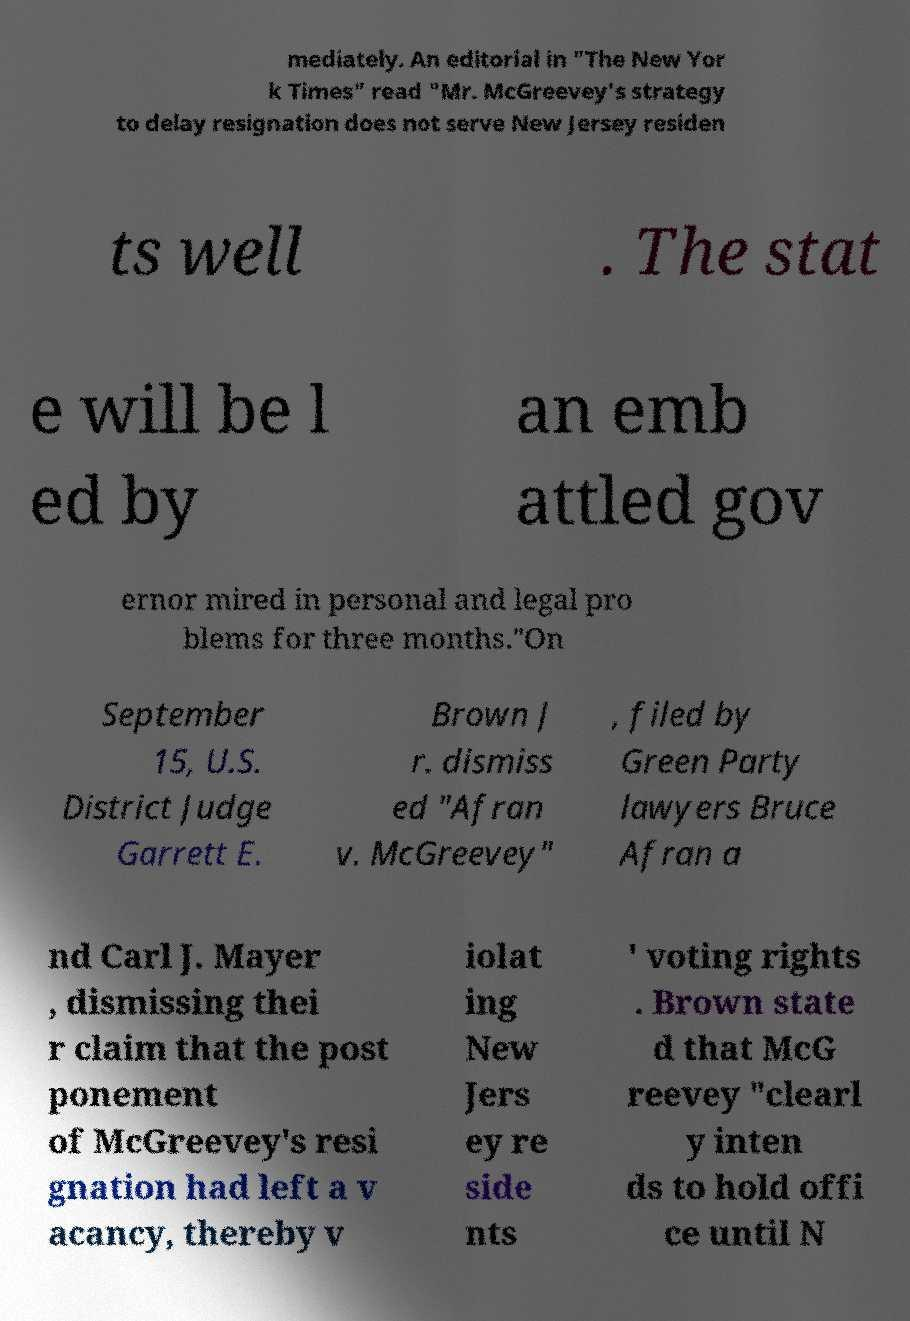I need the written content from this picture converted into text. Can you do that? mediately. An editorial in "The New Yor k Times" read "Mr. McGreevey's strategy to delay resignation does not serve New Jersey residen ts well . The stat e will be l ed by an emb attled gov ernor mired in personal and legal pro blems for three months."On September 15, U.S. District Judge Garrett E. Brown J r. dismiss ed "Afran v. McGreevey" , filed by Green Party lawyers Bruce Afran a nd Carl J. Mayer , dismissing thei r claim that the post ponement of McGreevey's resi gnation had left a v acancy, thereby v iolat ing New Jers ey re side nts ' voting rights . Brown state d that McG reevey "clearl y inten ds to hold offi ce until N 